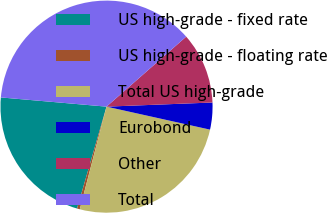Convert chart to OTSL. <chart><loc_0><loc_0><loc_500><loc_500><pie_chart><fcel>US high-grade - fixed rate<fcel>US high-grade - floating rate<fcel>Total US high-grade<fcel>Eurobond<fcel>Other<fcel>Total<nl><fcel>21.9%<fcel>0.43%<fcel>25.57%<fcel>4.1%<fcel>10.85%<fcel>37.14%<nl></chart> 